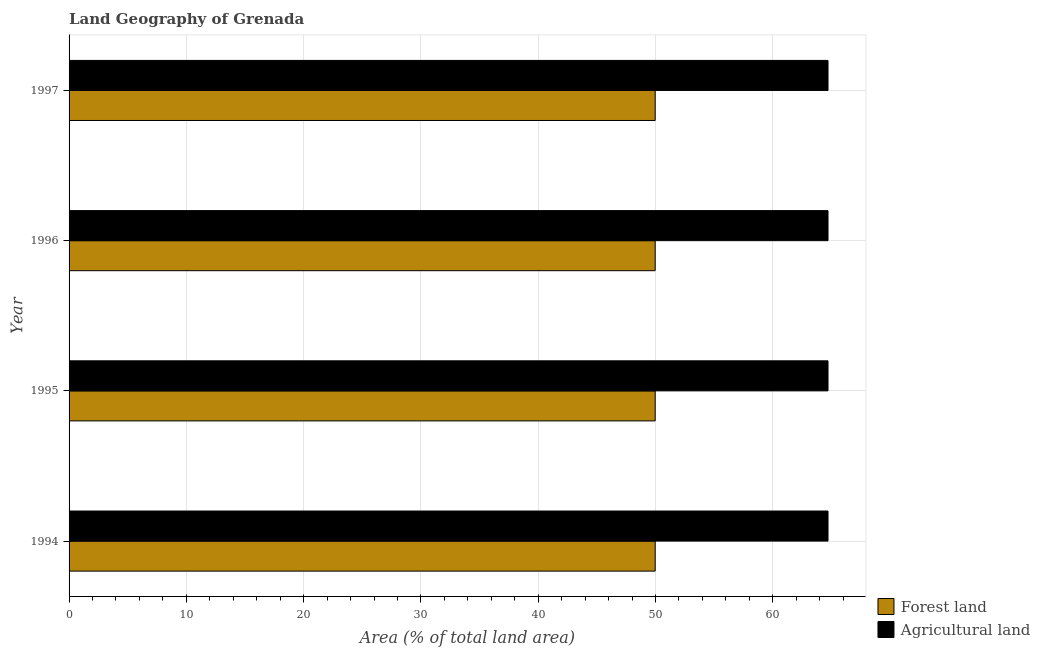How many different coloured bars are there?
Provide a succinct answer. 2. How many bars are there on the 3rd tick from the top?
Make the answer very short. 2. What is the label of the 4th group of bars from the top?
Your answer should be very brief. 1994. What is the percentage of land area under forests in 1995?
Make the answer very short. 49.97. Across all years, what is the maximum percentage of land area under forests?
Provide a succinct answer. 49.97. Across all years, what is the minimum percentage of land area under agriculture?
Offer a terse response. 64.71. In which year was the percentage of land area under forests minimum?
Your answer should be very brief. 1994. What is the total percentage of land area under agriculture in the graph?
Offer a terse response. 258.82. What is the difference between the percentage of land area under forests in 1996 and the percentage of land area under agriculture in 1997?
Offer a terse response. -14.74. What is the average percentage of land area under forests per year?
Your answer should be very brief. 49.97. In the year 1996, what is the difference between the percentage of land area under agriculture and percentage of land area under forests?
Your answer should be very brief. 14.73. What is the ratio of the percentage of land area under agriculture in 1996 to that in 1997?
Offer a terse response. 1. Is the difference between the percentage of land area under agriculture in 1994 and 1995 greater than the difference between the percentage of land area under forests in 1994 and 1995?
Your answer should be compact. No. What is the difference between the highest and the second highest percentage of land area under forests?
Ensure brevity in your answer.  0. What is the difference between the highest and the lowest percentage of land area under agriculture?
Give a very brief answer. 0. In how many years, is the percentage of land area under forests greater than the average percentage of land area under forests taken over all years?
Give a very brief answer. 0. Is the sum of the percentage of land area under forests in 1994 and 1997 greater than the maximum percentage of land area under agriculture across all years?
Offer a very short reply. Yes. What does the 1st bar from the top in 1994 represents?
Your answer should be very brief. Agricultural land. What does the 2nd bar from the bottom in 1997 represents?
Provide a succinct answer. Agricultural land. Are all the bars in the graph horizontal?
Offer a very short reply. Yes. Are the values on the major ticks of X-axis written in scientific E-notation?
Ensure brevity in your answer.  No. Does the graph contain any zero values?
Your answer should be compact. No. How many legend labels are there?
Give a very brief answer. 2. How are the legend labels stacked?
Offer a terse response. Vertical. What is the title of the graph?
Your answer should be very brief. Land Geography of Grenada. What is the label or title of the X-axis?
Your answer should be very brief. Area (% of total land area). What is the label or title of the Y-axis?
Provide a short and direct response. Year. What is the Area (% of total land area) of Forest land in 1994?
Ensure brevity in your answer.  49.97. What is the Area (% of total land area) in Agricultural land in 1994?
Give a very brief answer. 64.71. What is the Area (% of total land area) of Forest land in 1995?
Offer a very short reply. 49.97. What is the Area (% of total land area) in Agricultural land in 1995?
Offer a very short reply. 64.71. What is the Area (% of total land area) of Forest land in 1996?
Ensure brevity in your answer.  49.97. What is the Area (% of total land area) in Agricultural land in 1996?
Offer a very short reply. 64.71. What is the Area (% of total land area) of Forest land in 1997?
Give a very brief answer. 49.97. What is the Area (% of total land area) in Agricultural land in 1997?
Your answer should be very brief. 64.71. Across all years, what is the maximum Area (% of total land area) of Forest land?
Give a very brief answer. 49.97. Across all years, what is the maximum Area (% of total land area) of Agricultural land?
Offer a terse response. 64.71. Across all years, what is the minimum Area (% of total land area) of Forest land?
Ensure brevity in your answer.  49.97. Across all years, what is the minimum Area (% of total land area) of Agricultural land?
Offer a very short reply. 64.71. What is the total Area (% of total land area) of Forest land in the graph?
Provide a succinct answer. 199.88. What is the total Area (% of total land area) in Agricultural land in the graph?
Keep it short and to the point. 258.82. What is the difference between the Area (% of total land area) of Forest land in 1994 and that in 1995?
Provide a succinct answer. 0. What is the difference between the Area (% of total land area) in Agricultural land in 1994 and that in 1995?
Your answer should be very brief. 0. What is the difference between the Area (% of total land area) in Agricultural land in 1994 and that in 1996?
Provide a succinct answer. 0. What is the difference between the Area (% of total land area) of Agricultural land in 1994 and that in 1997?
Provide a succinct answer. 0. What is the difference between the Area (% of total land area) in Forest land in 1995 and that in 1997?
Ensure brevity in your answer.  0. What is the difference between the Area (% of total land area) of Forest land in 1996 and that in 1997?
Your answer should be very brief. 0. What is the difference between the Area (% of total land area) in Agricultural land in 1996 and that in 1997?
Your answer should be compact. 0. What is the difference between the Area (% of total land area) in Forest land in 1994 and the Area (% of total land area) in Agricultural land in 1995?
Your response must be concise. -14.74. What is the difference between the Area (% of total land area) in Forest land in 1994 and the Area (% of total land area) in Agricultural land in 1996?
Offer a very short reply. -14.74. What is the difference between the Area (% of total land area) in Forest land in 1994 and the Area (% of total land area) in Agricultural land in 1997?
Give a very brief answer. -14.74. What is the difference between the Area (% of total land area) in Forest land in 1995 and the Area (% of total land area) in Agricultural land in 1996?
Ensure brevity in your answer.  -14.74. What is the difference between the Area (% of total land area) in Forest land in 1995 and the Area (% of total land area) in Agricultural land in 1997?
Keep it short and to the point. -14.74. What is the difference between the Area (% of total land area) in Forest land in 1996 and the Area (% of total land area) in Agricultural land in 1997?
Keep it short and to the point. -14.74. What is the average Area (% of total land area) in Forest land per year?
Make the answer very short. 49.97. What is the average Area (% of total land area) in Agricultural land per year?
Your response must be concise. 64.71. In the year 1994, what is the difference between the Area (% of total land area) in Forest land and Area (% of total land area) in Agricultural land?
Provide a succinct answer. -14.74. In the year 1995, what is the difference between the Area (% of total land area) of Forest land and Area (% of total land area) of Agricultural land?
Make the answer very short. -14.74. In the year 1996, what is the difference between the Area (% of total land area) in Forest land and Area (% of total land area) in Agricultural land?
Offer a terse response. -14.74. In the year 1997, what is the difference between the Area (% of total land area) of Forest land and Area (% of total land area) of Agricultural land?
Offer a very short reply. -14.74. What is the ratio of the Area (% of total land area) of Forest land in 1994 to that in 1996?
Provide a short and direct response. 1. What is the ratio of the Area (% of total land area) of Forest land in 1994 to that in 1997?
Offer a terse response. 1. What is the ratio of the Area (% of total land area) of Forest land in 1995 to that in 1996?
Your answer should be compact. 1. What is the ratio of the Area (% of total land area) in Agricultural land in 1995 to that in 1996?
Make the answer very short. 1. What is the ratio of the Area (% of total land area) of Forest land in 1995 to that in 1997?
Ensure brevity in your answer.  1. What is the ratio of the Area (% of total land area) of Agricultural land in 1995 to that in 1997?
Give a very brief answer. 1. What is the difference between the highest and the second highest Area (% of total land area) of Forest land?
Provide a succinct answer. 0. What is the difference between the highest and the lowest Area (% of total land area) in Agricultural land?
Provide a short and direct response. 0. 